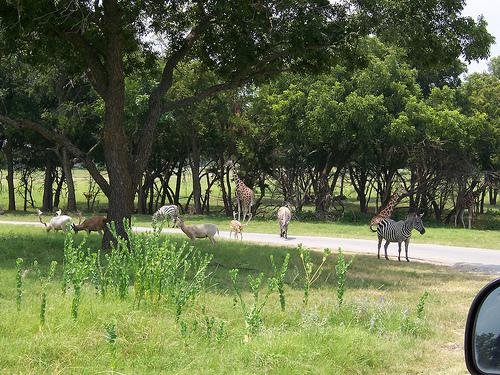Question: how many types of animals are there?
Choices:
A. 3.
B. 2.
C. 1.
D. 4.
Answer with the letter. Answer: A Question: what color are the zebra?
Choices:
A. Red and yellow.
B. Orange and Brown.
C. Black, white.
D. Pink and Purple.
Answer with the letter. Answer: C Question: what color are the giraffe spots?
Choices:
A. Yellow.
B. Orange.
C. Brown.
D. White.
Answer with the letter. Answer: C Question: where is this shot?
Choices:
A. Farm.
B. Safari.
C. Zoo.
D. Aquarium.
Answer with the letter. Answer: C Question: how many giraffe are shown?
Choices:
A. 4.
B. 5.
C. 6.
D. 3.
Answer with the letter. Answer: D 